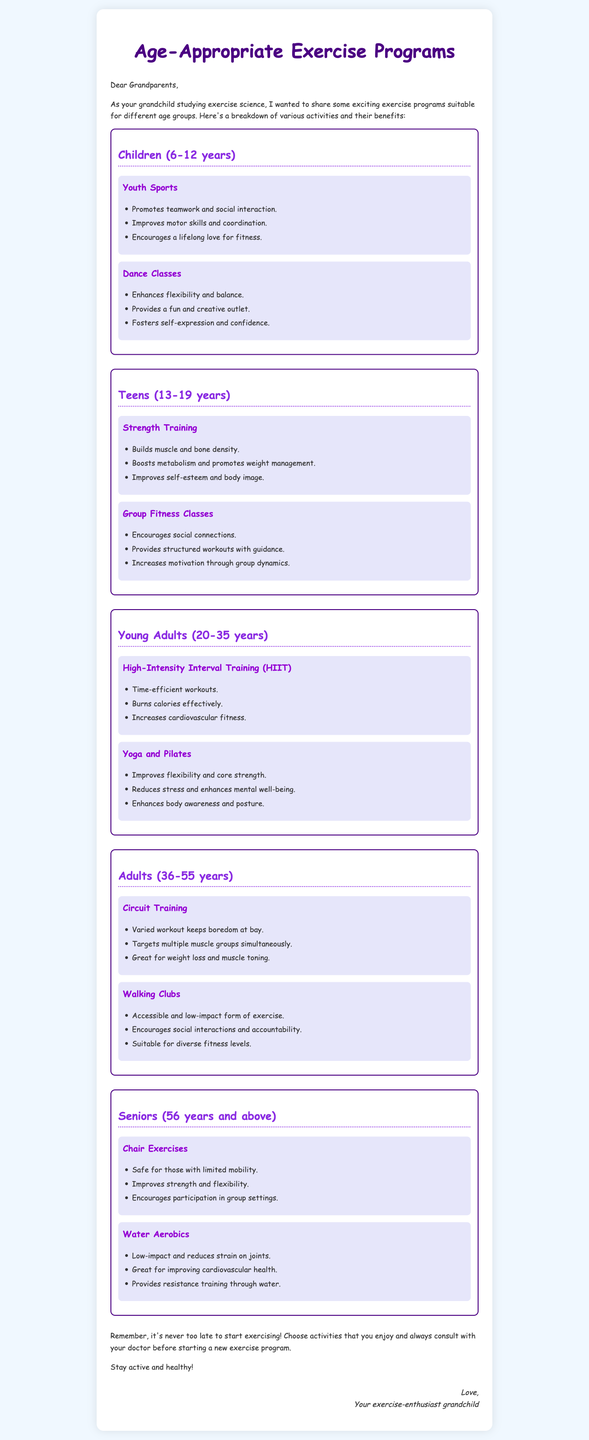What age group is targeted by Youth Sports? The document specifies Youth Sports for the age group of 6-12 years.
Answer: 6-12 years What are the benefits of Strength Training for teens? The document lists three benefits of Strength Training for teens: builds muscle and bone density, boosts metabolism, and improves self-esteem.
Answer: Builds muscle and bone density Which exercise program is suitable for seniors with limited mobility? The document specifically mentions Chair Exercises as safe for those with limited mobility.
Answer: Chair Exercises What type of training focuses on improving core strength and flexibility? The document identifies Yoga and Pilates as the type of training that enhances flexibility and core strength.
Answer: Yoga and Pilates How many exercise programs are suggested for Young Adults (20-35 years)? The document lists two exercise programs for the Young Adult age group: HIIT and Yoga/Pilates.
Answer: Two What is one advantage of Water Aerobics mentioned in the document? The document states that Water Aerobics is low-impact and reduces strain on joints.
Answer: Reduces strain on joints Which exercise program encourages social interactions for Adults (36-55 years)? The document mentions Walking Clubs, which encourage social interactions and accountability.
Answer: Walking Clubs What age group benefits from Dance Classes according to the document? The document indicates that Dance Classes are beneficial for Children (6-12 years).
Answer: Children (6-12 years) 